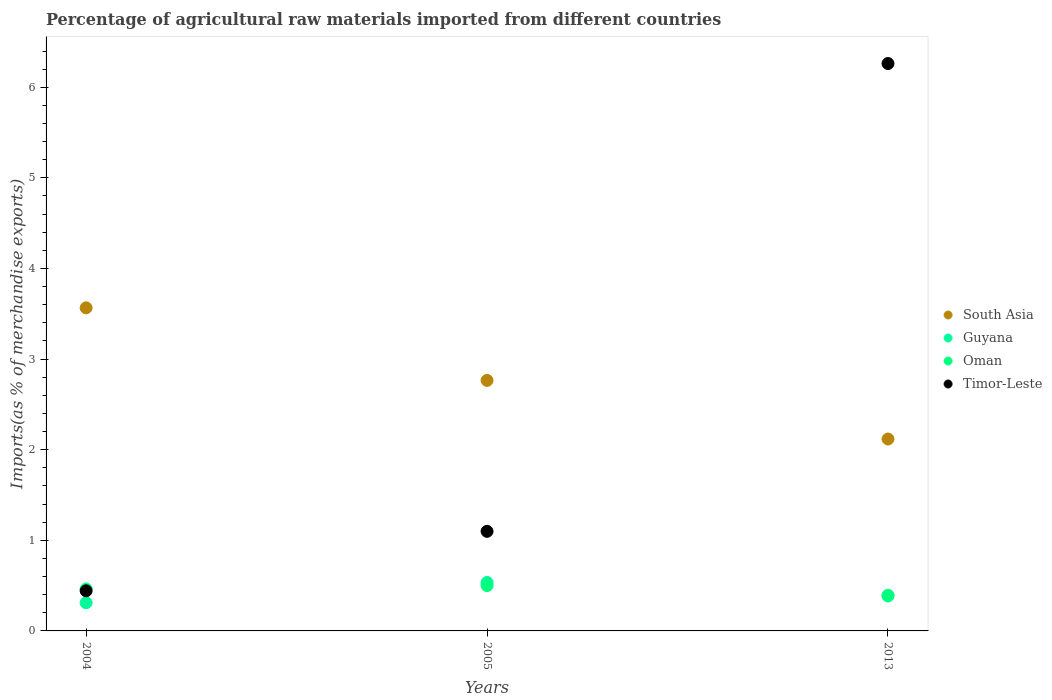Is the number of dotlines equal to the number of legend labels?
Keep it short and to the point. Yes. What is the percentage of imports to different countries in Timor-Leste in 2004?
Your answer should be compact. 0.44. Across all years, what is the maximum percentage of imports to different countries in Oman?
Your answer should be very brief. 0.5. Across all years, what is the minimum percentage of imports to different countries in South Asia?
Make the answer very short. 2.12. In which year was the percentage of imports to different countries in Timor-Leste maximum?
Give a very brief answer. 2013. In which year was the percentage of imports to different countries in Timor-Leste minimum?
Keep it short and to the point. 2004. What is the total percentage of imports to different countries in Guyana in the graph?
Keep it short and to the point. 1.23. What is the difference between the percentage of imports to different countries in Oman in 2004 and that in 2013?
Offer a terse response. 0.07. What is the difference between the percentage of imports to different countries in Guyana in 2013 and the percentage of imports to different countries in Oman in 2005?
Your response must be concise. -0.11. What is the average percentage of imports to different countries in Oman per year?
Keep it short and to the point. 0.45. In the year 2004, what is the difference between the percentage of imports to different countries in South Asia and percentage of imports to different countries in Oman?
Make the answer very short. 3.1. In how many years, is the percentage of imports to different countries in South Asia greater than 3.8 %?
Your answer should be very brief. 0. What is the ratio of the percentage of imports to different countries in Guyana in 2005 to that in 2013?
Your response must be concise. 1.39. What is the difference between the highest and the second highest percentage of imports to different countries in Guyana?
Your answer should be very brief. 0.15. What is the difference between the highest and the lowest percentage of imports to different countries in Oman?
Your response must be concise. 0.11. In how many years, is the percentage of imports to different countries in South Asia greater than the average percentage of imports to different countries in South Asia taken over all years?
Ensure brevity in your answer.  1. Is the sum of the percentage of imports to different countries in Guyana in 2004 and 2013 greater than the maximum percentage of imports to different countries in Timor-Leste across all years?
Offer a terse response. No. Is it the case that in every year, the sum of the percentage of imports to different countries in Oman and percentage of imports to different countries in Timor-Leste  is greater than the sum of percentage of imports to different countries in South Asia and percentage of imports to different countries in Guyana?
Provide a short and direct response. Yes. Is it the case that in every year, the sum of the percentage of imports to different countries in South Asia and percentage of imports to different countries in Oman  is greater than the percentage of imports to different countries in Timor-Leste?
Ensure brevity in your answer.  No. Is the percentage of imports to different countries in Timor-Leste strictly greater than the percentage of imports to different countries in Oman over the years?
Offer a very short reply. No. How many dotlines are there?
Your answer should be compact. 4. Does the graph contain grids?
Provide a succinct answer. No. What is the title of the graph?
Your response must be concise. Percentage of agricultural raw materials imported from different countries. Does "Korea (Republic)" appear as one of the legend labels in the graph?
Your response must be concise. No. What is the label or title of the Y-axis?
Your response must be concise. Imports(as % of merchandise exports). What is the Imports(as % of merchandise exports) in South Asia in 2004?
Make the answer very short. 3.57. What is the Imports(as % of merchandise exports) in Guyana in 2004?
Your answer should be very brief. 0.31. What is the Imports(as % of merchandise exports) in Oman in 2004?
Your response must be concise. 0.46. What is the Imports(as % of merchandise exports) in Timor-Leste in 2004?
Provide a succinct answer. 0.44. What is the Imports(as % of merchandise exports) in South Asia in 2005?
Offer a very short reply. 2.76. What is the Imports(as % of merchandise exports) in Guyana in 2005?
Keep it short and to the point. 0.53. What is the Imports(as % of merchandise exports) in Oman in 2005?
Offer a very short reply. 0.5. What is the Imports(as % of merchandise exports) in Timor-Leste in 2005?
Keep it short and to the point. 1.1. What is the Imports(as % of merchandise exports) of South Asia in 2013?
Ensure brevity in your answer.  2.12. What is the Imports(as % of merchandise exports) in Guyana in 2013?
Ensure brevity in your answer.  0.39. What is the Imports(as % of merchandise exports) in Oman in 2013?
Your response must be concise. 0.39. What is the Imports(as % of merchandise exports) of Timor-Leste in 2013?
Your answer should be compact. 6.26. Across all years, what is the maximum Imports(as % of merchandise exports) of South Asia?
Keep it short and to the point. 3.57. Across all years, what is the maximum Imports(as % of merchandise exports) of Guyana?
Ensure brevity in your answer.  0.53. Across all years, what is the maximum Imports(as % of merchandise exports) in Oman?
Provide a succinct answer. 0.5. Across all years, what is the maximum Imports(as % of merchandise exports) in Timor-Leste?
Keep it short and to the point. 6.26. Across all years, what is the minimum Imports(as % of merchandise exports) in South Asia?
Provide a short and direct response. 2.12. Across all years, what is the minimum Imports(as % of merchandise exports) in Guyana?
Give a very brief answer. 0.31. Across all years, what is the minimum Imports(as % of merchandise exports) in Oman?
Your answer should be very brief. 0.39. Across all years, what is the minimum Imports(as % of merchandise exports) in Timor-Leste?
Your answer should be compact. 0.44. What is the total Imports(as % of merchandise exports) in South Asia in the graph?
Offer a very short reply. 8.45. What is the total Imports(as % of merchandise exports) in Guyana in the graph?
Provide a succinct answer. 1.23. What is the total Imports(as % of merchandise exports) of Oman in the graph?
Ensure brevity in your answer.  1.36. What is the total Imports(as % of merchandise exports) of Timor-Leste in the graph?
Your response must be concise. 7.8. What is the difference between the Imports(as % of merchandise exports) of South Asia in 2004 and that in 2005?
Offer a terse response. 0.8. What is the difference between the Imports(as % of merchandise exports) of Guyana in 2004 and that in 2005?
Make the answer very short. -0.22. What is the difference between the Imports(as % of merchandise exports) in Oman in 2004 and that in 2005?
Provide a succinct answer. -0.04. What is the difference between the Imports(as % of merchandise exports) in Timor-Leste in 2004 and that in 2005?
Ensure brevity in your answer.  -0.66. What is the difference between the Imports(as % of merchandise exports) of South Asia in 2004 and that in 2013?
Provide a succinct answer. 1.45. What is the difference between the Imports(as % of merchandise exports) of Guyana in 2004 and that in 2013?
Provide a short and direct response. -0.07. What is the difference between the Imports(as % of merchandise exports) of Oman in 2004 and that in 2013?
Ensure brevity in your answer.  0.07. What is the difference between the Imports(as % of merchandise exports) in Timor-Leste in 2004 and that in 2013?
Offer a terse response. -5.82. What is the difference between the Imports(as % of merchandise exports) of South Asia in 2005 and that in 2013?
Ensure brevity in your answer.  0.65. What is the difference between the Imports(as % of merchandise exports) in Guyana in 2005 and that in 2013?
Your response must be concise. 0.15. What is the difference between the Imports(as % of merchandise exports) of Oman in 2005 and that in 2013?
Keep it short and to the point. 0.11. What is the difference between the Imports(as % of merchandise exports) of Timor-Leste in 2005 and that in 2013?
Provide a short and direct response. -5.16. What is the difference between the Imports(as % of merchandise exports) of South Asia in 2004 and the Imports(as % of merchandise exports) of Guyana in 2005?
Your answer should be very brief. 3.03. What is the difference between the Imports(as % of merchandise exports) in South Asia in 2004 and the Imports(as % of merchandise exports) in Oman in 2005?
Your response must be concise. 3.07. What is the difference between the Imports(as % of merchandise exports) of South Asia in 2004 and the Imports(as % of merchandise exports) of Timor-Leste in 2005?
Offer a very short reply. 2.47. What is the difference between the Imports(as % of merchandise exports) of Guyana in 2004 and the Imports(as % of merchandise exports) of Oman in 2005?
Provide a succinct answer. -0.19. What is the difference between the Imports(as % of merchandise exports) of Guyana in 2004 and the Imports(as % of merchandise exports) of Timor-Leste in 2005?
Give a very brief answer. -0.79. What is the difference between the Imports(as % of merchandise exports) in Oman in 2004 and the Imports(as % of merchandise exports) in Timor-Leste in 2005?
Make the answer very short. -0.64. What is the difference between the Imports(as % of merchandise exports) in South Asia in 2004 and the Imports(as % of merchandise exports) in Guyana in 2013?
Provide a short and direct response. 3.18. What is the difference between the Imports(as % of merchandise exports) in South Asia in 2004 and the Imports(as % of merchandise exports) in Oman in 2013?
Your answer should be compact. 3.17. What is the difference between the Imports(as % of merchandise exports) in South Asia in 2004 and the Imports(as % of merchandise exports) in Timor-Leste in 2013?
Offer a terse response. -2.7. What is the difference between the Imports(as % of merchandise exports) in Guyana in 2004 and the Imports(as % of merchandise exports) in Oman in 2013?
Provide a short and direct response. -0.08. What is the difference between the Imports(as % of merchandise exports) in Guyana in 2004 and the Imports(as % of merchandise exports) in Timor-Leste in 2013?
Give a very brief answer. -5.95. What is the difference between the Imports(as % of merchandise exports) of Oman in 2004 and the Imports(as % of merchandise exports) of Timor-Leste in 2013?
Provide a short and direct response. -5.8. What is the difference between the Imports(as % of merchandise exports) in South Asia in 2005 and the Imports(as % of merchandise exports) in Guyana in 2013?
Ensure brevity in your answer.  2.38. What is the difference between the Imports(as % of merchandise exports) of South Asia in 2005 and the Imports(as % of merchandise exports) of Oman in 2013?
Keep it short and to the point. 2.37. What is the difference between the Imports(as % of merchandise exports) in South Asia in 2005 and the Imports(as % of merchandise exports) in Timor-Leste in 2013?
Ensure brevity in your answer.  -3.5. What is the difference between the Imports(as % of merchandise exports) of Guyana in 2005 and the Imports(as % of merchandise exports) of Oman in 2013?
Keep it short and to the point. 0.14. What is the difference between the Imports(as % of merchandise exports) of Guyana in 2005 and the Imports(as % of merchandise exports) of Timor-Leste in 2013?
Your answer should be very brief. -5.73. What is the difference between the Imports(as % of merchandise exports) in Oman in 2005 and the Imports(as % of merchandise exports) in Timor-Leste in 2013?
Ensure brevity in your answer.  -5.76. What is the average Imports(as % of merchandise exports) of South Asia per year?
Your answer should be compact. 2.82. What is the average Imports(as % of merchandise exports) of Guyana per year?
Give a very brief answer. 0.41. What is the average Imports(as % of merchandise exports) in Oman per year?
Offer a very short reply. 0.45. What is the average Imports(as % of merchandise exports) in Timor-Leste per year?
Keep it short and to the point. 2.6. In the year 2004, what is the difference between the Imports(as % of merchandise exports) in South Asia and Imports(as % of merchandise exports) in Guyana?
Your answer should be compact. 3.25. In the year 2004, what is the difference between the Imports(as % of merchandise exports) of South Asia and Imports(as % of merchandise exports) of Oman?
Your response must be concise. 3.1. In the year 2004, what is the difference between the Imports(as % of merchandise exports) of South Asia and Imports(as % of merchandise exports) of Timor-Leste?
Offer a very short reply. 3.12. In the year 2004, what is the difference between the Imports(as % of merchandise exports) in Guyana and Imports(as % of merchandise exports) in Oman?
Keep it short and to the point. -0.15. In the year 2004, what is the difference between the Imports(as % of merchandise exports) of Guyana and Imports(as % of merchandise exports) of Timor-Leste?
Provide a short and direct response. -0.13. In the year 2004, what is the difference between the Imports(as % of merchandise exports) in Oman and Imports(as % of merchandise exports) in Timor-Leste?
Ensure brevity in your answer.  0.02. In the year 2005, what is the difference between the Imports(as % of merchandise exports) of South Asia and Imports(as % of merchandise exports) of Guyana?
Provide a short and direct response. 2.23. In the year 2005, what is the difference between the Imports(as % of merchandise exports) in South Asia and Imports(as % of merchandise exports) in Oman?
Provide a succinct answer. 2.26. In the year 2005, what is the difference between the Imports(as % of merchandise exports) of South Asia and Imports(as % of merchandise exports) of Timor-Leste?
Keep it short and to the point. 1.67. In the year 2005, what is the difference between the Imports(as % of merchandise exports) of Guyana and Imports(as % of merchandise exports) of Oman?
Your answer should be compact. 0.03. In the year 2005, what is the difference between the Imports(as % of merchandise exports) of Guyana and Imports(as % of merchandise exports) of Timor-Leste?
Make the answer very short. -0.56. In the year 2005, what is the difference between the Imports(as % of merchandise exports) in Oman and Imports(as % of merchandise exports) in Timor-Leste?
Make the answer very short. -0.6. In the year 2013, what is the difference between the Imports(as % of merchandise exports) in South Asia and Imports(as % of merchandise exports) in Guyana?
Keep it short and to the point. 1.73. In the year 2013, what is the difference between the Imports(as % of merchandise exports) of South Asia and Imports(as % of merchandise exports) of Oman?
Make the answer very short. 1.73. In the year 2013, what is the difference between the Imports(as % of merchandise exports) of South Asia and Imports(as % of merchandise exports) of Timor-Leste?
Keep it short and to the point. -4.14. In the year 2013, what is the difference between the Imports(as % of merchandise exports) in Guyana and Imports(as % of merchandise exports) in Oman?
Give a very brief answer. -0.01. In the year 2013, what is the difference between the Imports(as % of merchandise exports) in Guyana and Imports(as % of merchandise exports) in Timor-Leste?
Provide a short and direct response. -5.88. In the year 2013, what is the difference between the Imports(as % of merchandise exports) in Oman and Imports(as % of merchandise exports) in Timor-Leste?
Your answer should be compact. -5.87. What is the ratio of the Imports(as % of merchandise exports) of South Asia in 2004 to that in 2005?
Provide a succinct answer. 1.29. What is the ratio of the Imports(as % of merchandise exports) of Guyana in 2004 to that in 2005?
Provide a short and direct response. 0.58. What is the ratio of the Imports(as % of merchandise exports) of Oman in 2004 to that in 2005?
Your answer should be compact. 0.93. What is the ratio of the Imports(as % of merchandise exports) of Timor-Leste in 2004 to that in 2005?
Your answer should be compact. 0.4. What is the ratio of the Imports(as % of merchandise exports) of South Asia in 2004 to that in 2013?
Make the answer very short. 1.68. What is the ratio of the Imports(as % of merchandise exports) of Guyana in 2004 to that in 2013?
Keep it short and to the point. 0.81. What is the ratio of the Imports(as % of merchandise exports) of Oman in 2004 to that in 2013?
Provide a short and direct response. 1.18. What is the ratio of the Imports(as % of merchandise exports) of Timor-Leste in 2004 to that in 2013?
Provide a short and direct response. 0.07. What is the ratio of the Imports(as % of merchandise exports) of South Asia in 2005 to that in 2013?
Offer a very short reply. 1.31. What is the ratio of the Imports(as % of merchandise exports) in Guyana in 2005 to that in 2013?
Provide a succinct answer. 1.39. What is the ratio of the Imports(as % of merchandise exports) of Oman in 2005 to that in 2013?
Make the answer very short. 1.27. What is the ratio of the Imports(as % of merchandise exports) of Timor-Leste in 2005 to that in 2013?
Your answer should be compact. 0.18. What is the difference between the highest and the second highest Imports(as % of merchandise exports) of South Asia?
Provide a short and direct response. 0.8. What is the difference between the highest and the second highest Imports(as % of merchandise exports) in Guyana?
Your answer should be very brief. 0.15. What is the difference between the highest and the second highest Imports(as % of merchandise exports) in Oman?
Give a very brief answer. 0.04. What is the difference between the highest and the second highest Imports(as % of merchandise exports) of Timor-Leste?
Ensure brevity in your answer.  5.16. What is the difference between the highest and the lowest Imports(as % of merchandise exports) of South Asia?
Offer a very short reply. 1.45. What is the difference between the highest and the lowest Imports(as % of merchandise exports) of Guyana?
Keep it short and to the point. 0.22. What is the difference between the highest and the lowest Imports(as % of merchandise exports) of Oman?
Provide a succinct answer. 0.11. What is the difference between the highest and the lowest Imports(as % of merchandise exports) in Timor-Leste?
Provide a short and direct response. 5.82. 